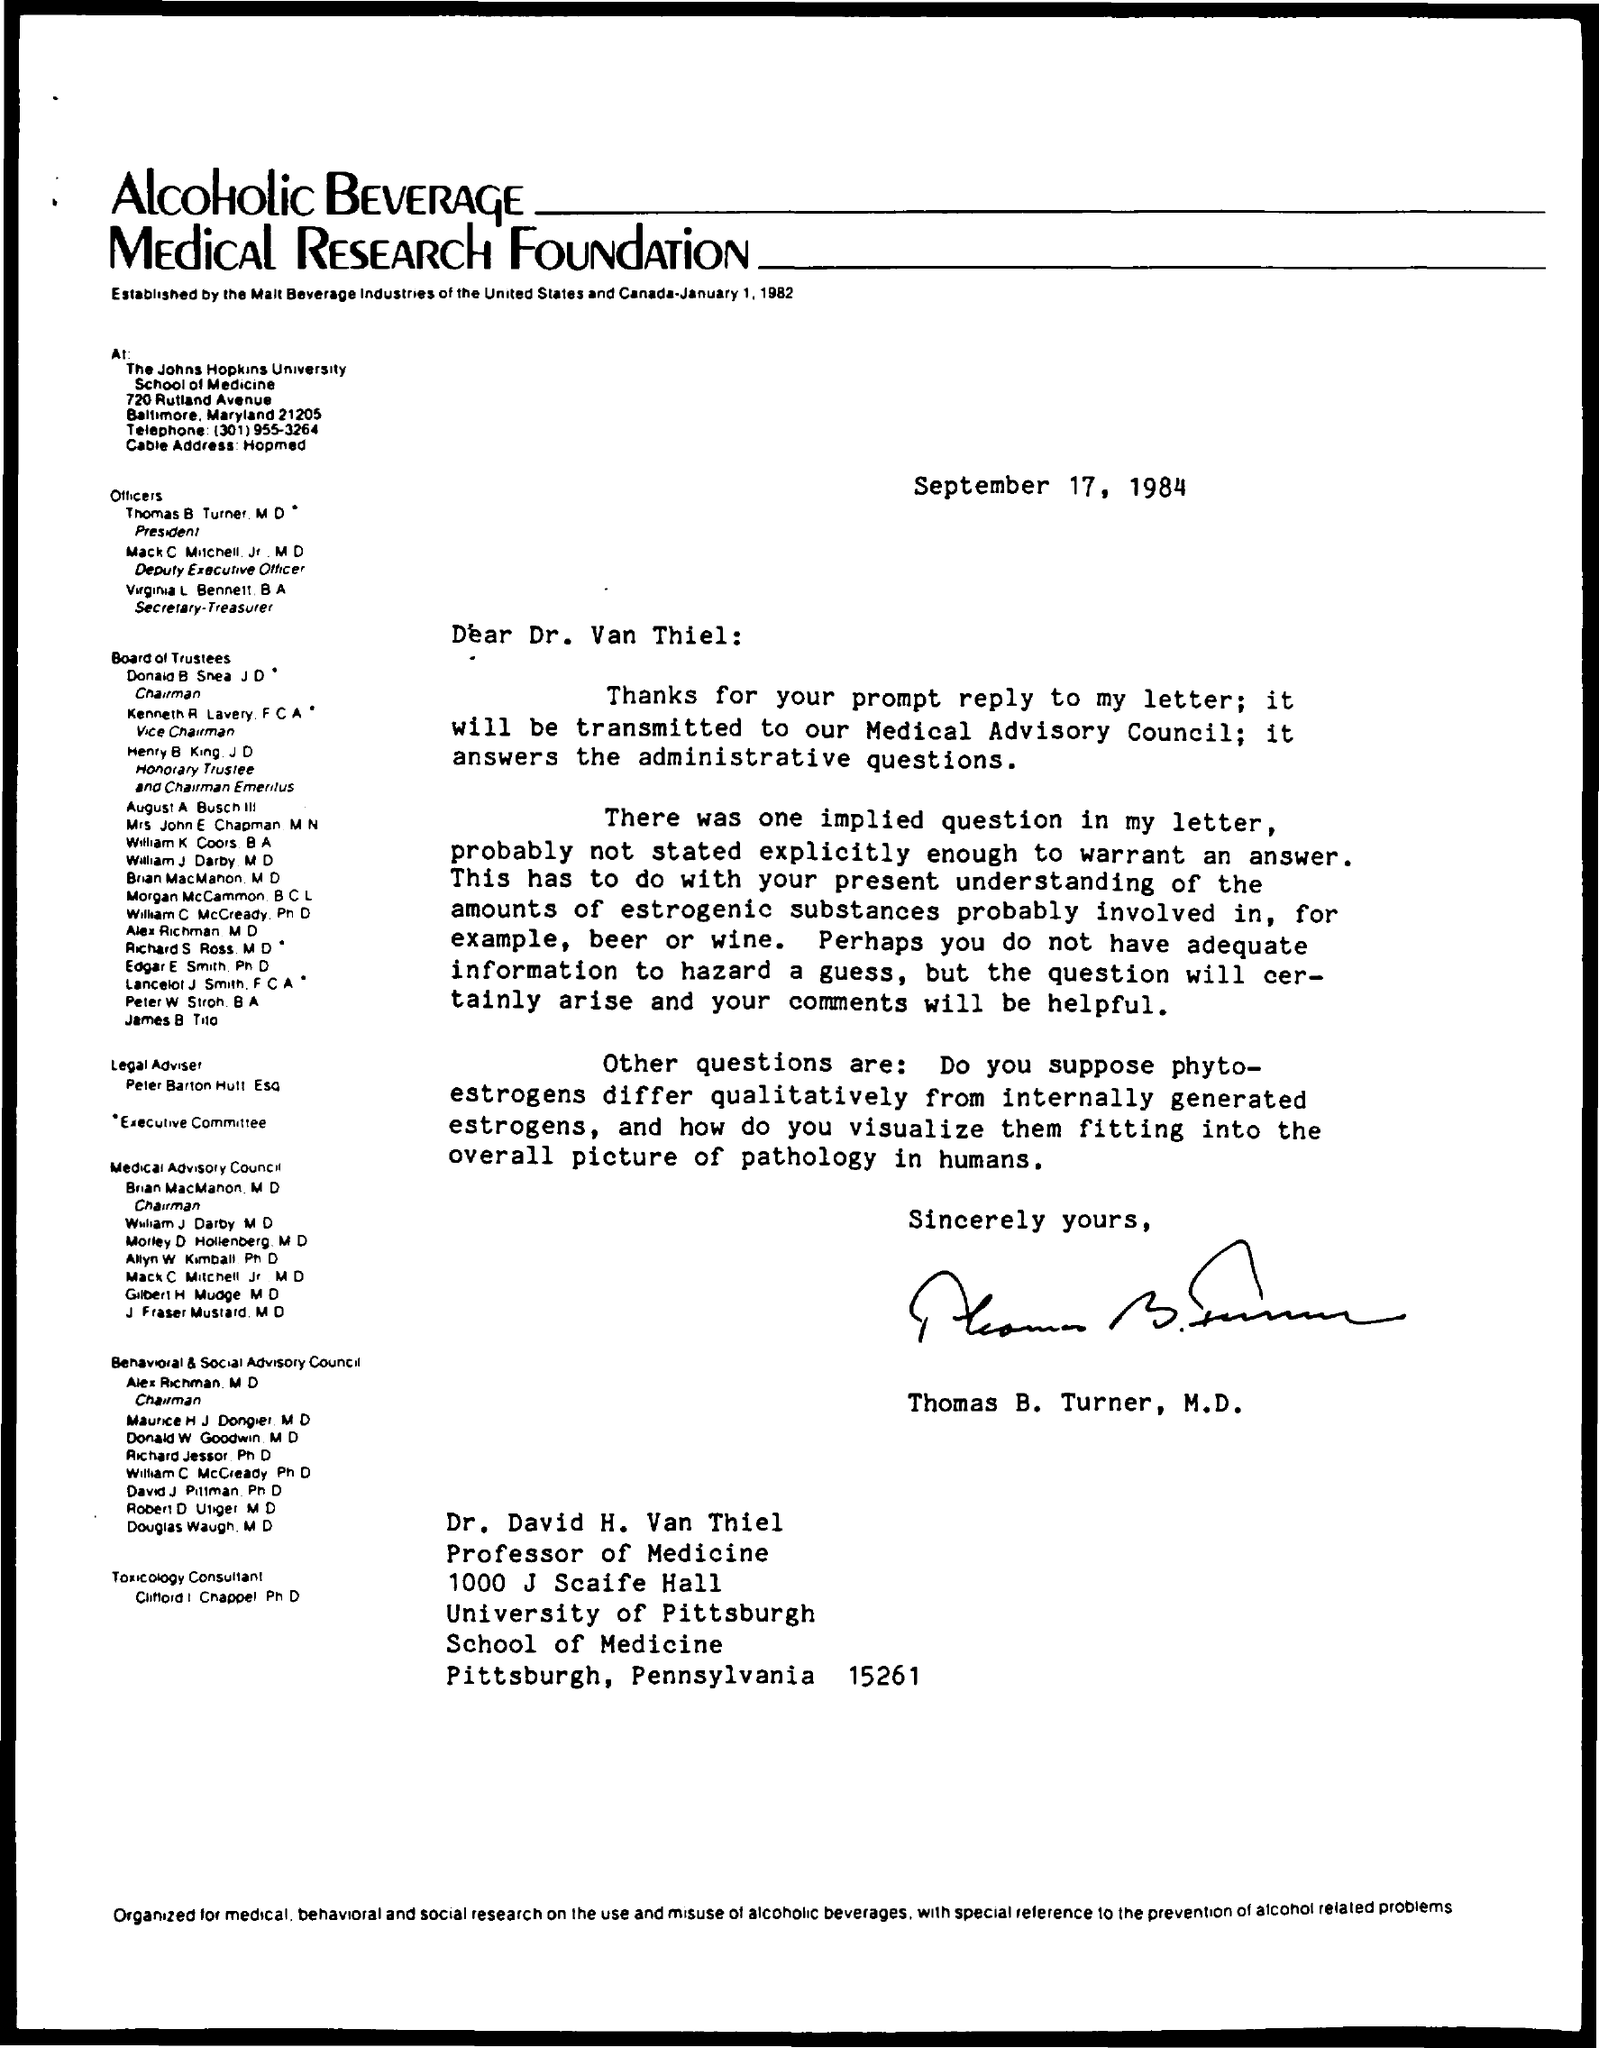Mention a couple of crucial points in this snapshot. The date on the document is September 17, 1984. The letter is from Thomas B. Turner, M.D. The letter is addressed to Dr. Van Thiel. 